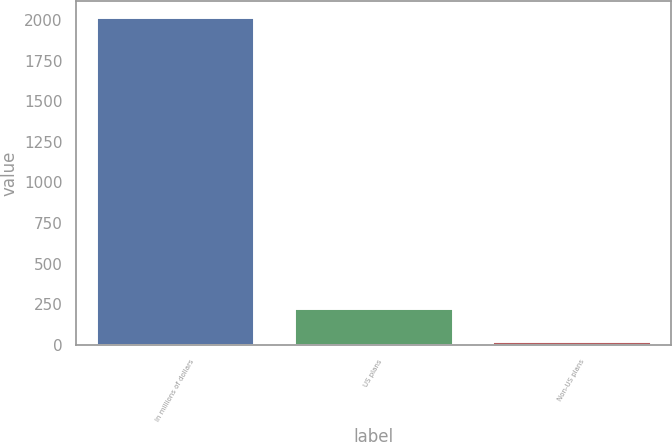<chart> <loc_0><loc_0><loc_500><loc_500><bar_chart><fcel>In millions of dollars<fcel>US plans<fcel>Non-US plans<nl><fcel>2017<fcel>226<fcel>27<nl></chart> 